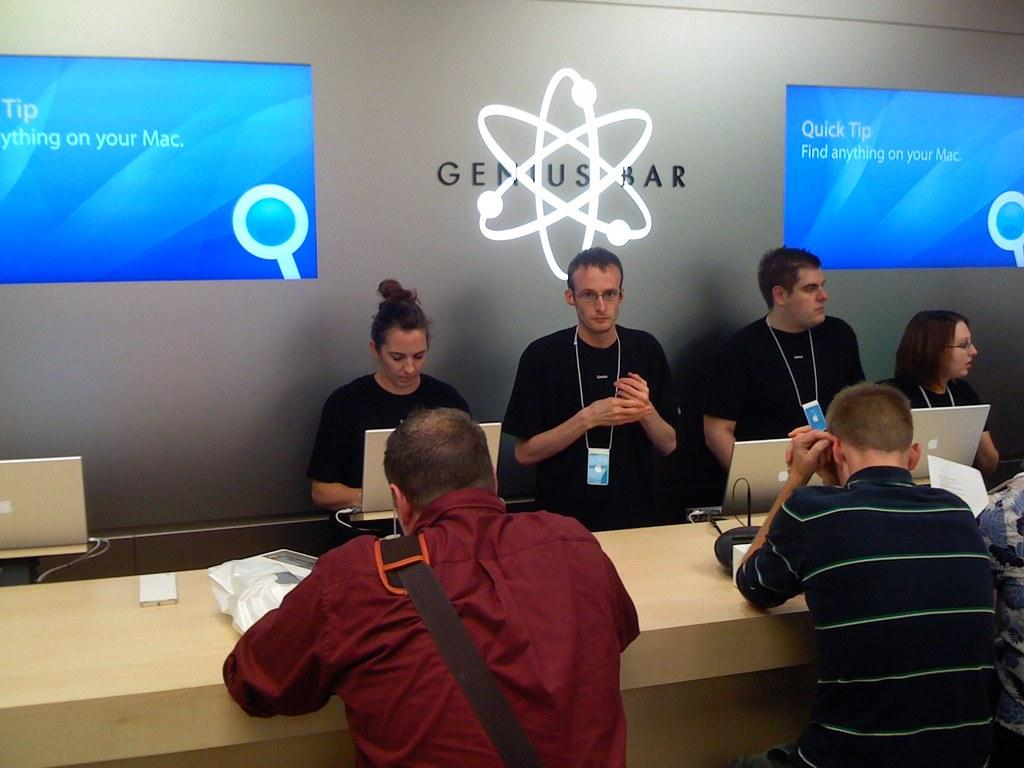How many people are in the image? There is a group of people in the image, but the exact number is not specified. What is the platform used for in the image? The platform is present in the image, but its purpose is not mentioned. What are the laptops being used for in the image? The laptops are visible in the image, but their usage is not described. What objects can be seen in the image? There are some objects in the image, but their specific nature is not detailed. What is displayed on the screens in the background of the image? There are screens visible in the background of the image, but their content is not described. Can you tell me how many giants are walking down the street in the image? There are no giants or streets present in the image; it features a group of people, a platform, laptops, and screens in the background. 